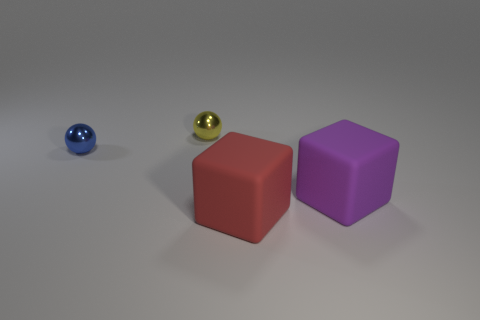What can you say about the colors of the objects? The image features a selective palette of colors which includes a deep blue for the small ball on the far left, a shiny gold for the centrally located sphere, a solid red for the cube on the central-right, and a rich purple for the cube on the right. Each color is distinct, and the objects appear to be matte, except for the shiny gold sphere. This range of colors, in combination with the objects' geometric shapes, creates a visually stimulating scene that could represent concepts such as diversity or contrast. 